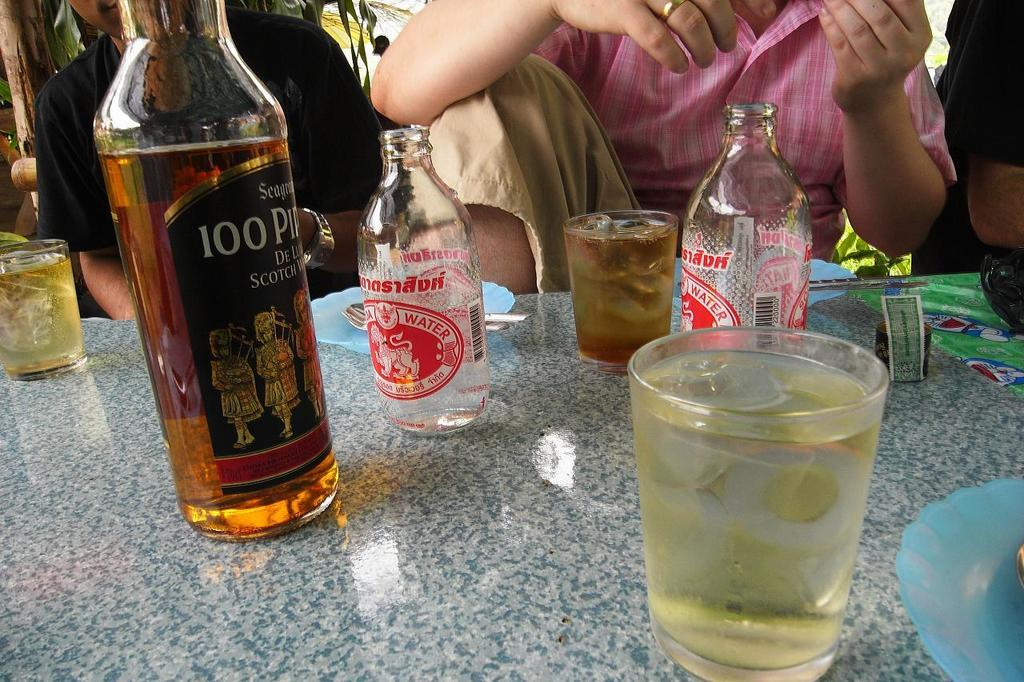<image>
Create a compact narrative representing the image presented. Bottle of alcohol with a label that says 100 on it. 